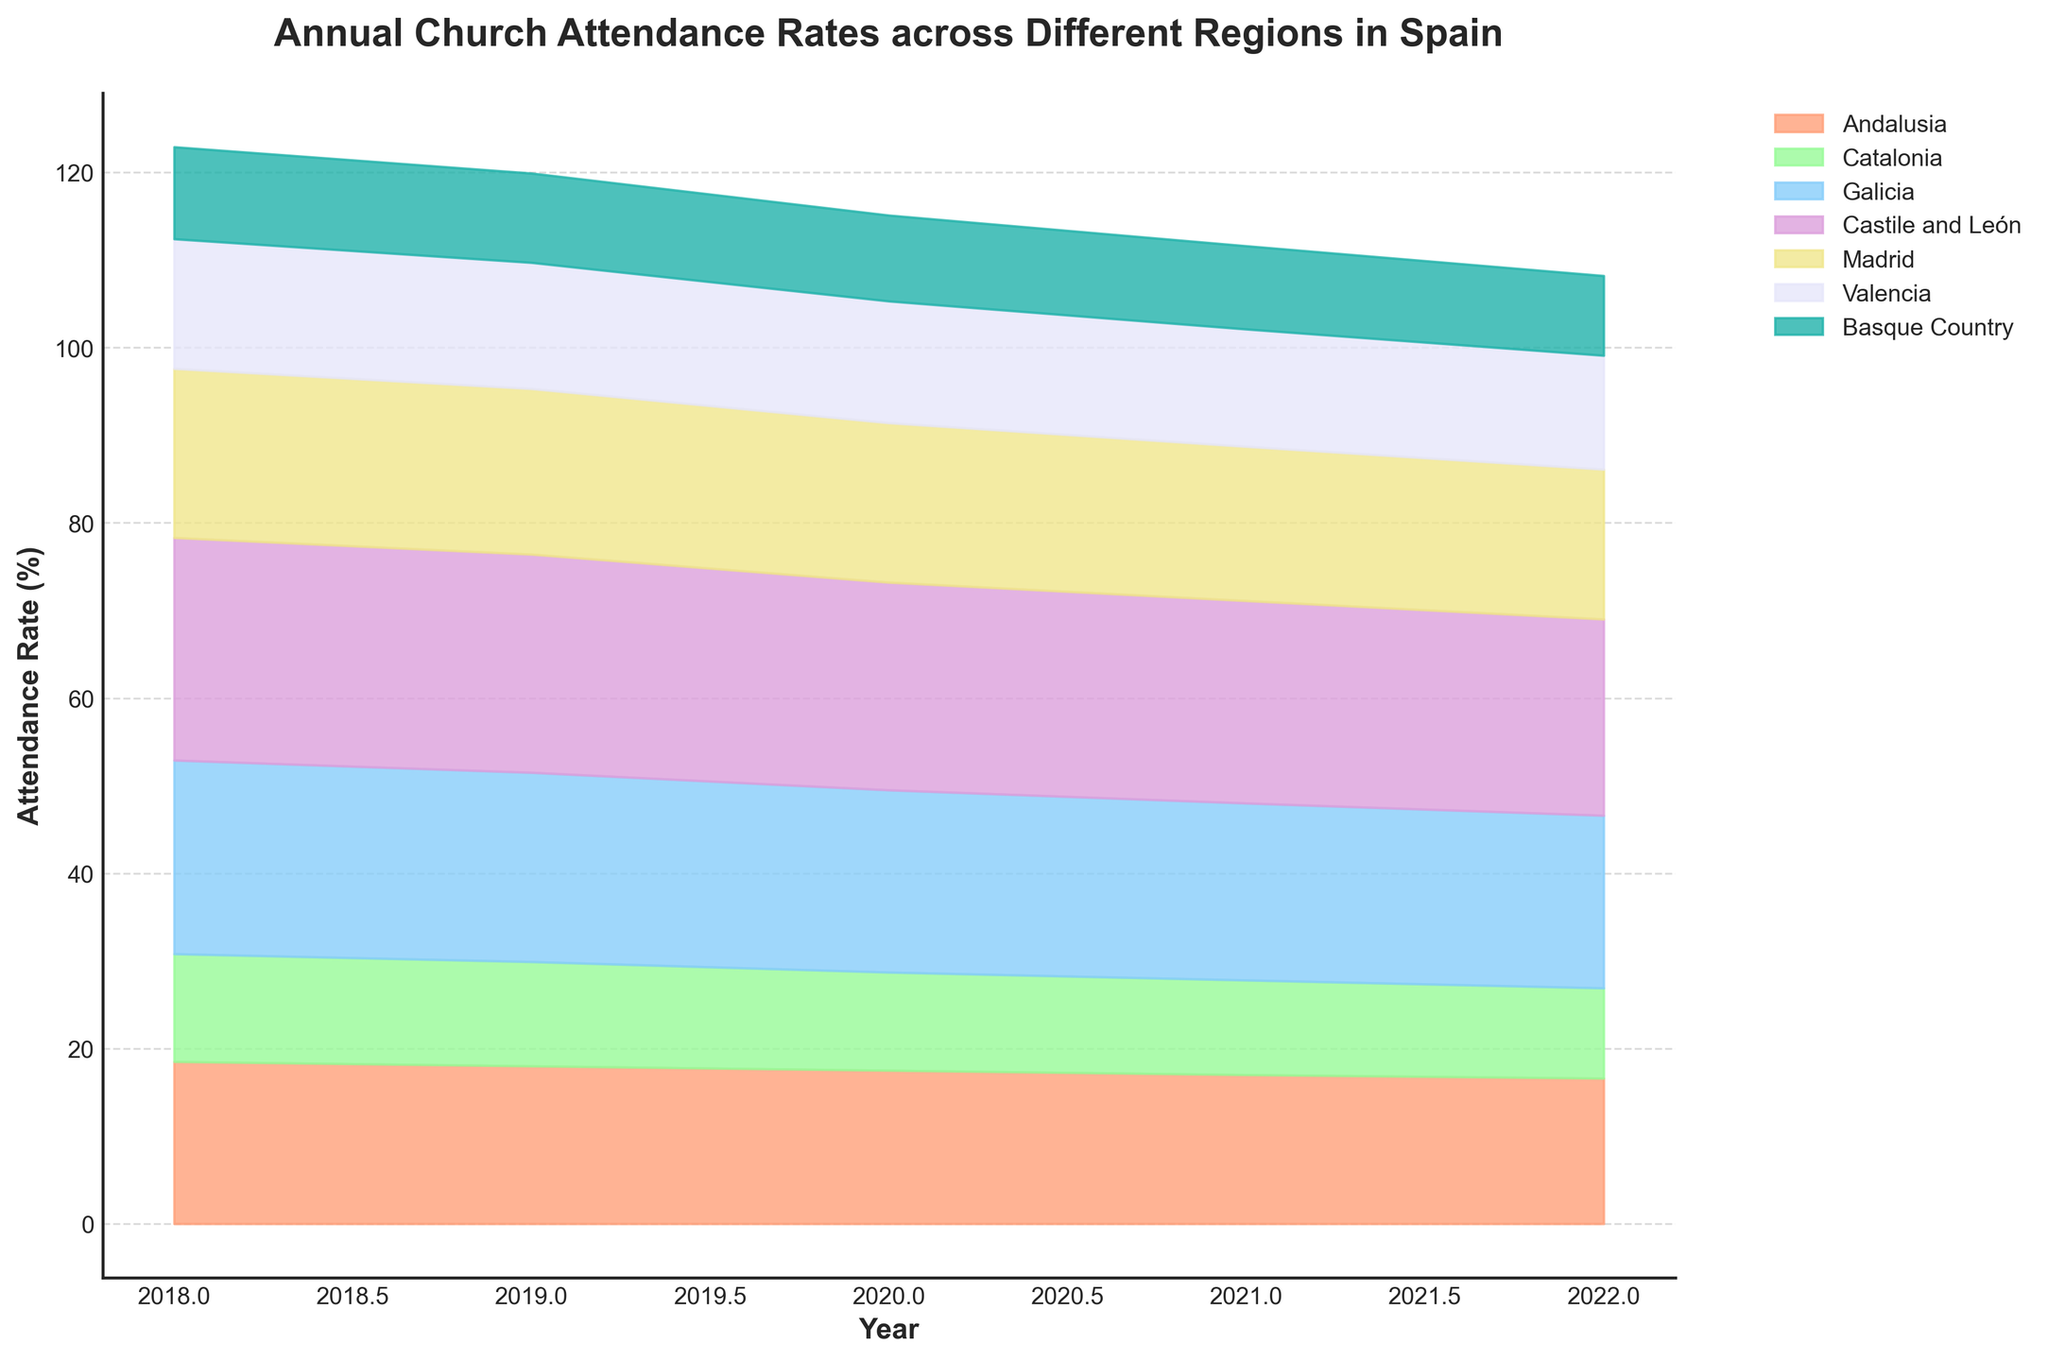What is the title of the graph? The title of the graph is usually prominently displayed at the top of the figure in larger and bold font. This particular title is "Annual Church Attendance Rates across Different Regions in Spain," which is clearly specified in the title code section and visually evident in the figure.
Answer: Annual Church Attendance Rates across Different Regions in Spain Which year had the highest church attendance rate in Castile and León? To determine the year with the highest attendance rate for Castile and León, observe the plotted stream for Castile and León and identify the peak position. Refer to the x-axis for the corresponding year. The highest rate on the graph is in 2018 for Castile and León.
Answer: 2018 Compare the church attendance rates between Andalusia and Catalonia in 2021. Which one had a higher rate? Look at the plotted streams for both regions in 2021. Observe their heights and compare them. The stream for Andalusia is higher than for Catalonia in 2021.
Answer: Andalusia How did the overall church attendance rate trend change from 2018 to 2022 for Valencia? Examine the stream for Valencia across the years from 2018 to 2022. Notice the gradual decrease in the height of the stream, indicating a decline in church attendance rates.
Answer: Decrease Which region showed the most significant decrease in church attendance rate from 2018 to 2022? Observe the streams for all regions comparing their heights between 2018 and 2022. The Basque Country's stream shows the most significant decrease in height from 10.5% in 2018 to 9.1% in 2022.
Answer: Basque Country In which year did Madrid have the lowest church attendance rate? Look at the stream for Madrid and identify the point where it has the lowest height. The lowest attendance rate appears in 2022.
Answer: 2022 What is the overall trend for Galicia’s church attendance rate from 2018 to 2022? Observe the stream for Galicia from 2018 to 2022. Notice the general decrease in height, showing a declining trend in church attendance rate.
Answer: Decrease 